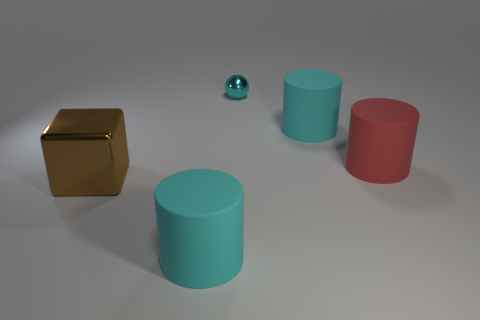What number of cyan things have the same size as the red cylinder?
Give a very brief answer. 2. There is a big matte cylinder in front of the red object; are there any large red rubber things right of it?
Your answer should be compact. Yes. What number of objects are cyan metal spheres or matte cylinders?
Your answer should be very brief. 4. What is the color of the big matte thing behind the big red matte thing that is on the right side of the cyan rubber cylinder that is on the left side of the small sphere?
Offer a very short reply. Cyan. Is there anything else that has the same color as the metal sphere?
Provide a succinct answer. Yes. Is the red matte cylinder the same size as the brown shiny thing?
Give a very brief answer. Yes. What number of objects are large matte cylinders in front of the big red matte cylinder or large rubber cylinders on the right side of the tiny cyan object?
Offer a terse response. 3. What material is the large cyan object behind the large matte thing that is in front of the red rubber cylinder made of?
Ensure brevity in your answer.  Rubber. How many other objects are the same material as the cyan sphere?
Ensure brevity in your answer.  1. Does the large brown shiny thing have the same shape as the cyan metallic thing?
Make the answer very short. No. 